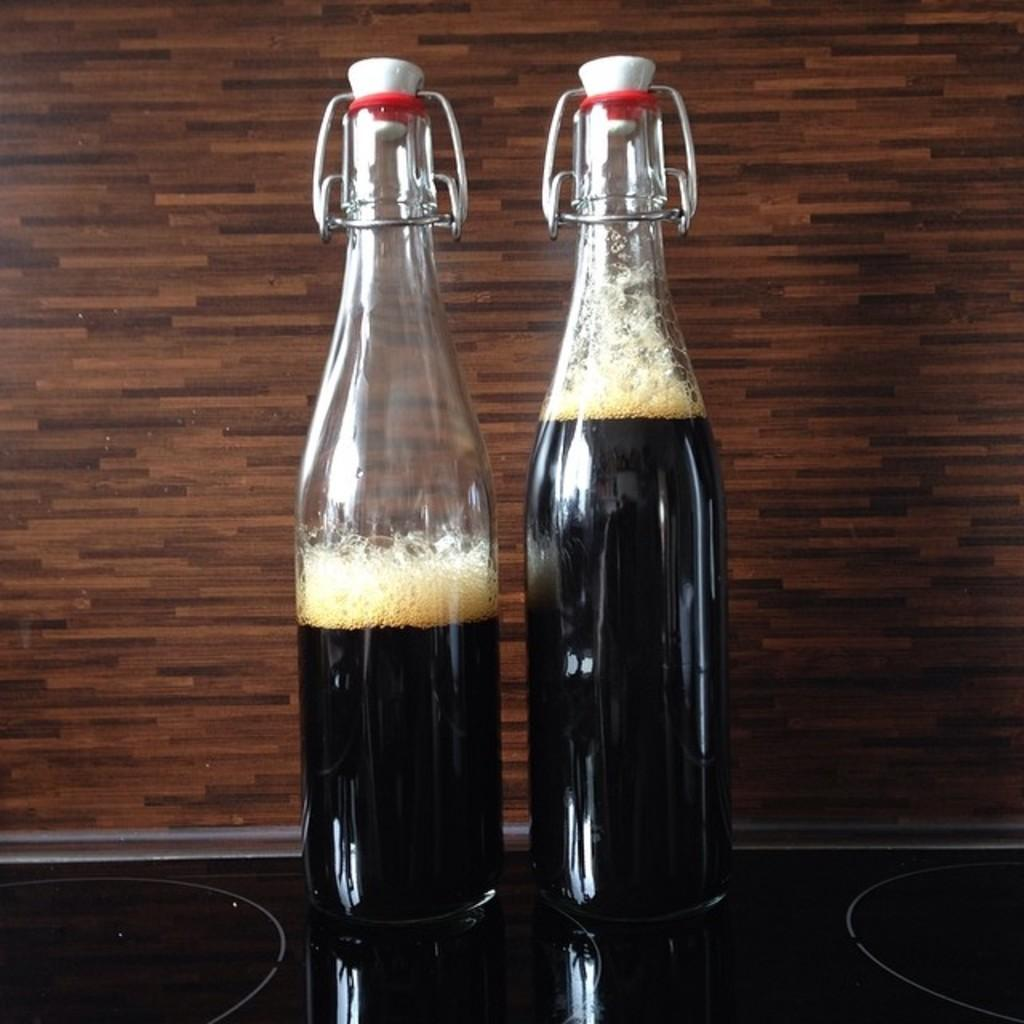How many wine bottles are visible in the image? There are two wine bottles in the image. Where are the wine bottles located in the image? The wine bottles are on a glass table. What type of relation does the shelf have with the wine bottles in the image? There is no shelf present in the image, so it cannot have a relation with the wine bottles. 